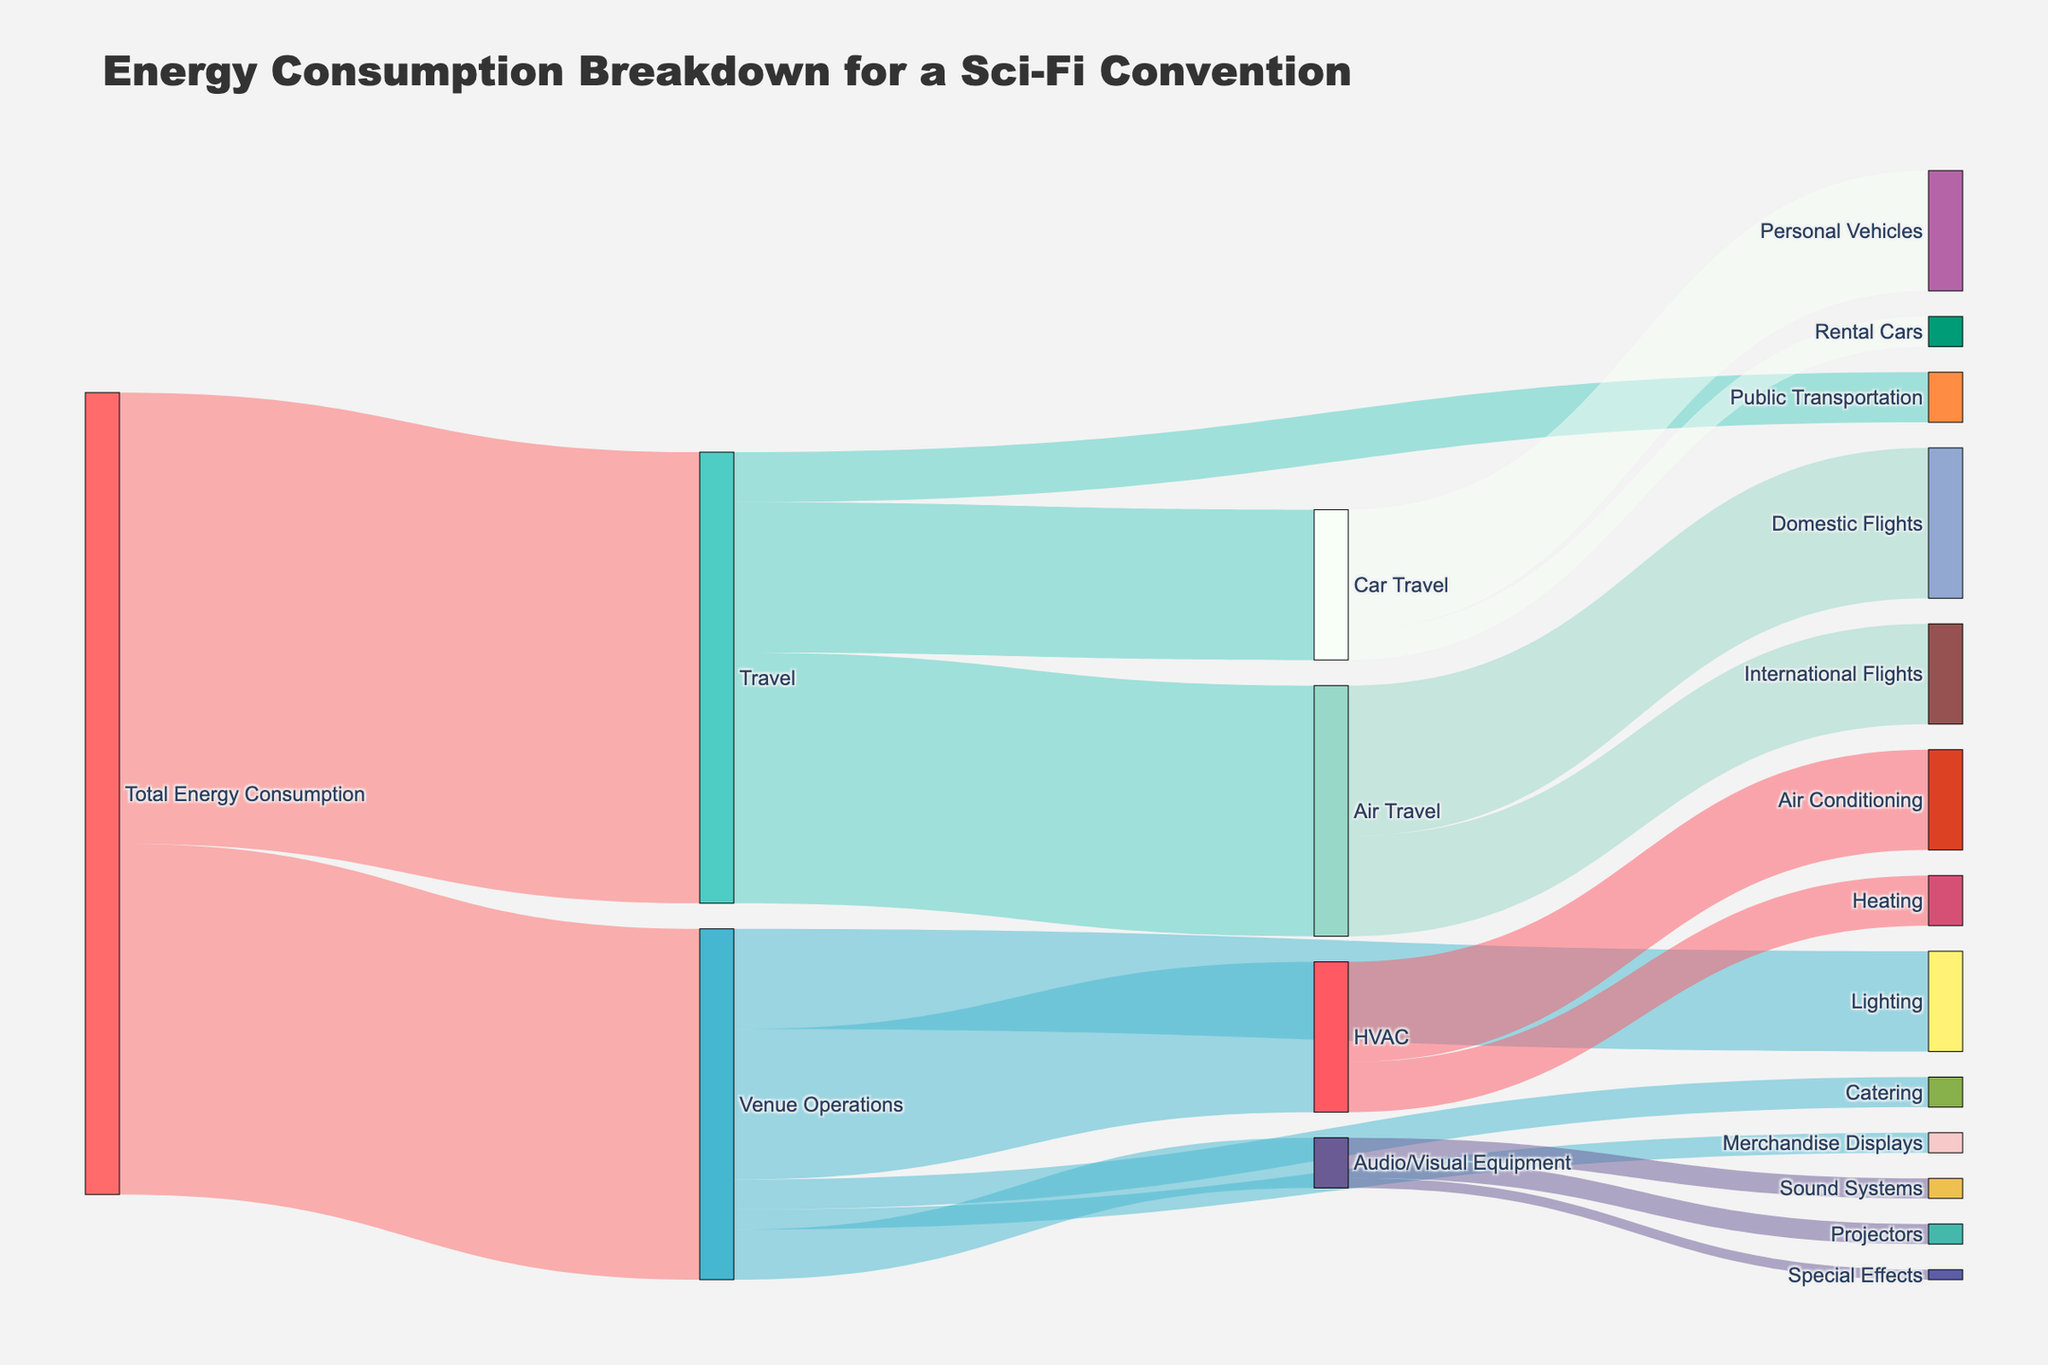What is the total energy consumption for Air Travel? To find the total energy consumption for Air Travel, we need to look at the values for Domestic Flights and International Flights under the Air Travel node in the diagram. Adding these two values together gives us 15,000 (Domestic Flights) + 10,000 (International Flights) = 25,000.
Answer: 25,000 Which category consumes more energy: Heating or Lighting? To compare the energy consumption for Heating and Lighting, we look at their respective values in the Venue Operations section of the Sankey diagram. Heating consumes 5,000 units of energy and Lighting consumes 10,000 units of energy.
Answer: Lighting What is the total energy consumption for Venue Operations? The total energy consumption for Venue Operations is directly given in the diagram under the main category "Total Energy Consumption → Venue Operations", which is 35,000.
Answer: 35,000 How much energy is consumed by Public Transportation? The energy consumption for Public Transportation can be found directly in the Travel section of the diagram, which shows a value of 5,000 units.
Answer: 5,000 Which subcategory under Audio/Visual Equipment consumes the least energy? Within the Audio/Visual Equipment category, we look at the energy values for Projectors, Sound Systems, and Special Effects. Special Effects consumes 1,000 units, which is the least.
Answer: Special Effects What is the combined energy consumption for Air Conditioning and Catering? To find the combined energy consumption for Air Conditioning and Catering, we add the values for both categories. Air Conditioning has 10,000 units and Catering has 3,000 units, giving us 10,000 + 3,000 = 13,000 units.
Answer: 13,000 Is the energy consumption for Personal Vehicles greater than for Rental Cars? To compare the energy consumption for Personal Vehicles and Rental Cars, we look at their values under Car Travel. Personal Vehicles consume 12,000 units and Rental Cars consume 3,000 units. 12,000 is greater than 3,000.
Answer: Yes What is the difference in energy consumption between Air Conditioning and Heating? The energy consumption for Air Conditioning is 10,000 units and for Heating is 5,000 units. The difference is 10,000 - 5,000 = 5,000 units.
Answer: 5,000 What is the second largest energy-consuming category within Travel? Within the Travel category, we total the values for Air Travel, Car Travel, and Public Transportation. Since these are 25,000, 15,000, and 5,000 units respectively, Car Travel is the second largest.
Answer: Car Travel 